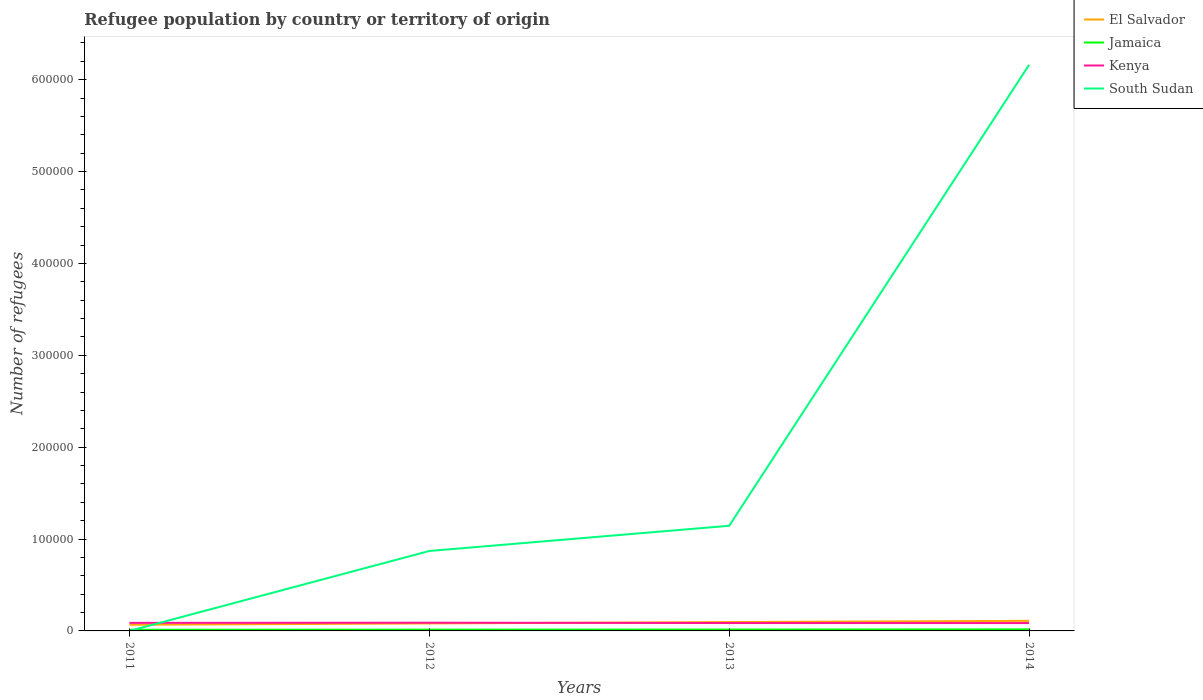Does the line corresponding to South Sudan intersect with the line corresponding to Kenya?
Make the answer very short. Yes. Across all years, what is the maximum number of refugees in El Salvador?
Provide a short and direct response. 6720. What is the total number of refugees in Kenya in the graph?
Your answer should be compact. 394. What is the difference between the highest and the second highest number of refugees in South Sudan?
Your answer should be very brief. 6.16e+05. Is the number of refugees in Jamaica strictly greater than the number of refugees in Kenya over the years?
Make the answer very short. Yes. How many years are there in the graph?
Your answer should be very brief. 4. Are the values on the major ticks of Y-axis written in scientific E-notation?
Offer a terse response. No. Does the graph contain any zero values?
Keep it short and to the point. No. Does the graph contain grids?
Provide a succinct answer. No. How many legend labels are there?
Your response must be concise. 4. What is the title of the graph?
Keep it short and to the point. Refugee population by country or territory of origin. Does "Slovak Republic" appear as one of the legend labels in the graph?
Keep it short and to the point. No. What is the label or title of the X-axis?
Ensure brevity in your answer.  Years. What is the label or title of the Y-axis?
Offer a very short reply. Number of refugees. What is the Number of refugees of El Salvador in 2011?
Ensure brevity in your answer.  6720. What is the Number of refugees of Jamaica in 2011?
Give a very brief answer. 1250. What is the Number of refugees of Kenya in 2011?
Offer a very short reply. 8745. What is the Number of refugees of South Sudan in 2011?
Provide a short and direct response. 1. What is the Number of refugees of El Salvador in 2012?
Offer a very short reply. 8171. What is the Number of refugees of Jamaica in 2012?
Your answer should be very brief. 1407. What is the Number of refugees in Kenya in 2012?
Make the answer very short. 8950. What is the Number of refugees of South Sudan in 2012?
Make the answer very short. 8.70e+04. What is the Number of refugees in El Salvador in 2013?
Keep it short and to the point. 9638. What is the Number of refugees in Jamaica in 2013?
Offer a terse response. 1503. What is the Number of refugees in Kenya in 2013?
Your answer should be very brief. 8589. What is the Number of refugees in South Sudan in 2013?
Give a very brief answer. 1.14e+05. What is the Number of refugees of El Salvador in 2014?
Give a very brief answer. 1.10e+04. What is the Number of refugees in Jamaica in 2014?
Your answer should be compact. 1692. What is the Number of refugees in Kenya in 2014?
Your answer should be compact. 8556. What is the Number of refugees of South Sudan in 2014?
Your answer should be compact. 6.16e+05. Across all years, what is the maximum Number of refugees in El Salvador?
Provide a succinct answer. 1.10e+04. Across all years, what is the maximum Number of refugees in Jamaica?
Offer a terse response. 1692. Across all years, what is the maximum Number of refugees of Kenya?
Your answer should be very brief. 8950. Across all years, what is the maximum Number of refugees of South Sudan?
Keep it short and to the point. 6.16e+05. Across all years, what is the minimum Number of refugees in El Salvador?
Ensure brevity in your answer.  6720. Across all years, what is the minimum Number of refugees in Jamaica?
Provide a succinct answer. 1250. Across all years, what is the minimum Number of refugees in Kenya?
Give a very brief answer. 8556. What is the total Number of refugees of El Salvador in the graph?
Your answer should be very brief. 3.55e+04. What is the total Number of refugees in Jamaica in the graph?
Give a very brief answer. 5852. What is the total Number of refugees in Kenya in the graph?
Ensure brevity in your answer.  3.48e+04. What is the total Number of refugees in South Sudan in the graph?
Offer a very short reply. 8.18e+05. What is the difference between the Number of refugees of El Salvador in 2011 and that in 2012?
Your answer should be very brief. -1451. What is the difference between the Number of refugees in Jamaica in 2011 and that in 2012?
Provide a succinct answer. -157. What is the difference between the Number of refugees in Kenya in 2011 and that in 2012?
Provide a short and direct response. -205. What is the difference between the Number of refugees in South Sudan in 2011 and that in 2012?
Ensure brevity in your answer.  -8.70e+04. What is the difference between the Number of refugees in El Salvador in 2011 and that in 2013?
Give a very brief answer. -2918. What is the difference between the Number of refugees in Jamaica in 2011 and that in 2013?
Your answer should be compact. -253. What is the difference between the Number of refugees of Kenya in 2011 and that in 2013?
Provide a short and direct response. 156. What is the difference between the Number of refugees in South Sudan in 2011 and that in 2013?
Your answer should be very brief. -1.14e+05. What is the difference between the Number of refugees of El Salvador in 2011 and that in 2014?
Provide a succinct answer. -4245. What is the difference between the Number of refugees in Jamaica in 2011 and that in 2014?
Provide a succinct answer. -442. What is the difference between the Number of refugees of Kenya in 2011 and that in 2014?
Your response must be concise. 189. What is the difference between the Number of refugees in South Sudan in 2011 and that in 2014?
Offer a terse response. -6.16e+05. What is the difference between the Number of refugees in El Salvador in 2012 and that in 2013?
Make the answer very short. -1467. What is the difference between the Number of refugees of Jamaica in 2012 and that in 2013?
Give a very brief answer. -96. What is the difference between the Number of refugees of Kenya in 2012 and that in 2013?
Your answer should be very brief. 361. What is the difference between the Number of refugees in South Sudan in 2012 and that in 2013?
Provide a succinct answer. -2.75e+04. What is the difference between the Number of refugees of El Salvador in 2012 and that in 2014?
Provide a succinct answer. -2794. What is the difference between the Number of refugees of Jamaica in 2012 and that in 2014?
Ensure brevity in your answer.  -285. What is the difference between the Number of refugees of Kenya in 2012 and that in 2014?
Keep it short and to the point. 394. What is the difference between the Number of refugees in South Sudan in 2012 and that in 2014?
Offer a terse response. -5.29e+05. What is the difference between the Number of refugees in El Salvador in 2013 and that in 2014?
Provide a short and direct response. -1327. What is the difference between the Number of refugees of Jamaica in 2013 and that in 2014?
Give a very brief answer. -189. What is the difference between the Number of refugees of South Sudan in 2013 and that in 2014?
Make the answer very short. -5.02e+05. What is the difference between the Number of refugees of El Salvador in 2011 and the Number of refugees of Jamaica in 2012?
Provide a short and direct response. 5313. What is the difference between the Number of refugees in El Salvador in 2011 and the Number of refugees in Kenya in 2012?
Your answer should be compact. -2230. What is the difference between the Number of refugees of El Salvador in 2011 and the Number of refugees of South Sudan in 2012?
Your response must be concise. -8.03e+04. What is the difference between the Number of refugees in Jamaica in 2011 and the Number of refugees in Kenya in 2012?
Keep it short and to the point. -7700. What is the difference between the Number of refugees in Jamaica in 2011 and the Number of refugees in South Sudan in 2012?
Offer a very short reply. -8.58e+04. What is the difference between the Number of refugees of Kenya in 2011 and the Number of refugees of South Sudan in 2012?
Ensure brevity in your answer.  -7.83e+04. What is the difference between the Number of refugees of El Salvador in 2011 and the Number of refugees of Jamaica in 2013?
Offer a terse response. 5217. What is the difference between the Number of refugees in El Salvador in 2011 and the Number of refugees in Kenya in 2013?
Give a very brief answer. -1869. What is the difference between the Number of refugees of El Salvador in 2011 and the Number of refugees of South Sudan in 2013?
Ensure brevity in your answer.  -1.08e+05. What is the difference between the Number of refugees in Jamaica in 2011 and the Number of refugees in Kenya in 2013?
Your response must be concise. -7339. What is the difference between the Number of refugees of Jamaica in 2011 and the Number of refugees of South Sudan in 2013?
Ensure brevity in your answer.  -1.13e+05. What is the difference between the Number of refugees in Kenya in 2011 and the Number of refugees in South Sudan in 2013?
Your response must be concise. -1.06e+05. What is the difference between the Number of refugees in El Salvador in 2011 and the Number of refugees in Jamaica in 2014?
Make the answer very short. 5028. What is the difference between the Number of refugees in El Salvador in 2011 and the Number of refugees in Kenya in 2014?
Provide a short and direct response. -1836. What is the difference between the Number of refugees of El Salvador in 2011 and the Number of refugees of South Sudan in 2014?
Offer a very short reply. -6.09e+05. What is the difference between the Number of refugees in Jamaica in 2011 and the Number of refugees in Kenya in 2014?
Ensure brevity in your answer.  -7306. What is the difference between the Number of refugees of Jamaica in 2011 and the Number of refugees of South Sudan in 2014?
Provide a succinct answer. -6.15e+05. What is the difference between the Number of refugees of Kenya in 2011 and the Number of refugees of South Sudan in 2014?
Provide a succinct answer. -6.07e+05. What is the difference between the Number of refugees in El Salvador in 2012 and the Number of refugees in Jamaica in 2013?
Provide a succinct answer. 6668. What is the difference between the Number of refugees of El Salvador in 2012 and the Number of refugees of Kenya in 2013?
Keep it short and to the point. -418. What is the difference between the Number of refugees of El Salvador in 2012 and the Number of refugees of South Sudan in 2013?
Your response must be concise. -1.06e+05. What is the difference between the Number of refugees in Jamaica in 2012 and the Number of refugees in Kenya in 2013?
Your answer should be very brief. -7182. What is the difference between the Number of refugees of Jamaica in 2012 and the Number of refugees of South Sudan in 2013?
Your response must be concise. -1.13e+05. What is the difference between the Number of refugees in Kenya in 2012 and the Number of refugees in South Sudan in 2013?
Offer a terse response. -1.06e+05. What is the difference between the Number of refugees of El Salvador in 2012 and the Number of refugees of Jamaica in 2014?
Your answer should be compact. 6479. What is the difference between the Number of refugees of El Salvador in 2012 and the Number of refugees of Kenya in 2014?
Your answer should be very brief. -385. What is the difference between the Number of refugees in El Salvador in 2012 and the Number of refugees in South Sudan in 2014?
Offer a very short reply. -6.08e+05. What is the difference between the Number of refugees in Jamaica in 2012 and the Number of refugees in Kenya in 2014?
Provide a succinct answer. -7149. What is the difference between the Number of refugees in Jamaica in 2012 and the Number of refugees in South Sudan in 2014?
Keep it short and to the point. -6.15e+05. What is the difference between the Number of refugees of Kenya in 2012 and the Number of refugees of South Sudan in 2014?
Your answer should be compact. -6.07e+05. What is the difference between the Number of refugees in El Salvador in 2013 and the Number of refugees in Jamaica in 2014?
Give a very brief answer. 7946. What is the difference between the Number of refugees in El Salvador in 2013 and the Number of refugees in Kenya in 2014?
Offer a terse response. 1082. What is the difference between the Number of refugees of El Salvador in 2013 and the Number of refugees of South Sudan in 2014?
Provide a succinct answer. -6.07e+05. What is the difference between the Number of refugees of Jamaica in 2013 and the Number of refugees of Kenya in 2014?
Your response must be concise. -7053. What is the difference between the Number of refugees in Jamaica in 2013 and the Number of refugees in South Sudan in 2014?
Offer a very short reply. -6.15e+05. What is the difference between the Number of refugees in Kenya in 2013 and the Number of refugees in South Sudan in 2014?
Provide a succinct answer. -6.08e+05. What is the average Number of refugees in El Salvador per year?
Your response must be concise. 8873.5. What is the average Number of refugees in Jamaica per year?
Your answer should be compact. 1463. What is the average Number of refugees in Kenya per year?
Ensure brevity in your answer.  8710. What is the average Number of refugees in South Sudan per year?
Ensure brevity in your answer.  2.04e+05. In the year 2011, what is the difference between the Number of refugees of El Salvador and Number of refugees of Jamaica?
Ensure brevity in your answer.  5470. In the year 2011, what is the difference between the Number of refugees in El Salvador and Number of refugees in Kenya?
Offer a terse response. -2025. In the year 2011, what is the difference between the Number of refugees in El Salvador and Number of refugees in South Sudan?
Provide a succinct answer. 6719. In the year 2011, what is the difference between the Number of refugees of Jamaica and Number of refugees of Kenya?
Make the answer very short. -7495. In the year 2011, what is the difference between the Number of refugees of Jamaica and Number of refugees of South Sudan?
Keep it short and to the point. 1249. In the year 2011, what is the difference between the Number of refugees in Kenya and Number of refugees in South Sudan?
Make the answer very short. 8744. In the year 2012, what is the difference between the Number of refugees of El Salvador and Number of refugees of Jamaica?
Provide a succinct answer. 6764. In the year 2012, what is the difference between the Number of refugees of El Salvador and Number of refugees of Kenya?
Offer a very short reply. -779. In the year 2012, what is the difference between the Number of refugees of El Salvador and Number of refugees of South Sudan?
Provide a short and direct response. -7.88e+04. In the year 2012, what is the difference between the Number of refugees of Jamaica and Number of refugees of Kenya?
Give a very brief answer. -7543. In the year 2012, what is the difference between the Number of refugees in Jamaica and Number of refugees in South Sudan?
Provide a short and direct response. -8.56e+04. In the year 2012, what is the difference between the Number of refugees in Kenya and Number of refugees in South Sudan?
Provide a succinct answer. -7.81e+04. In the year 2013, what is the difference between the Number of refugees of El Salvador and Number of refugees of Jamaica?
Provide a short and direct response. 8135. In the year 2013, what is the difference between the Number of refugees in El Salvador and Number of refugees in Kenya?
Offer a very short reply. 1049. In the year 2013, what is the difference between the Number of refugees of El Salvador and Number of refugees of South Sudan?
Your response must be concise. -1.05e+05. In the year 2013, what is the difference between the Number of refugees of Jamaica and Number of refugees of Kenya?
Your response must be concise. -7086. In the year 2013, what is the difference between the Number of refugees of Jamaica and Number of refugees of South Sudan?
Provide a short and direct response. -1.13e+05. In the year 2013, what is the difference between the Number of refugees in Kenya and Number of refugees in South Sudan?
Provide a succinct answer. -1.06e+05. In the year 2014, what is the difference between the Number of refugees of El Salvador and Number of refugees of Jamaica?
Offer a terse response. 9273. In the year 2014, what is the difference between the Number of refugees of El Salvador and Number of refugees of Kenya?
Give a very brief answer. 2409. In the year 2014, what is the difference between the Number of refugees of El Salvador and Number of refugees of South Sudan?
Your response must be concise. -6.05e+05. In the year 2014, what is the difference between the Number of refugees in Jamaica and Number of refugees in Kenya?
Make the answer very short. -6864. In the year 2014, what is the difference between the Number of refugees of Jamaica and Number of refugees of South Sudan?
Your answer should be compact. -6.14e+05. In the year 2014, what is the difference between the Number of refugees of Kenya and Number of refugees of South Sudan?
Provide a succinct answer. -6.08e+05. What is the ratio of the Number of refugees of El Salvador in 2011 to that in 2012?
Provide a short and direct response. 0.82. What is the ratio of the Number of refugees in Jamaica in 2011 to that in 2012?
Provide a succinct answer. 0.89. What is the ratio of the Number of refugees in Kenya in 2011 to that in 2012?
Your response must be concise. 0.98. What is the ratio of the Number of refugees in El Salvador in 2011 to that in 2013?
Provide a succinct answer. 0.7. What is the ratio of the Number of refugees of Jamaica in 2011 to that in 2013?
Your answer should be compact. 0.83. What is the ratio of the Number of refugees of Kenya in 2011 to that in 2013?
Offer a terse response. 1.02. What is the ratio of the Number of refugees of El Salvador in 2011 to that in 2014?
Ensure brevity in your answer.  0.61. What is the ratio of the Number of refugees in Jamaica in 2011 to that in 2014?
Offer a very short reply. 0.74. What is the ratio of the Number of refugees in Kenya in 2011 to that in 2014?
Your answer should be compact. 1.02. What is the ratio of the Number of refugees in South Sudan in 2011 to that in 2014?
Keep it short and to the point. 0. What is the ratio of the Number of refugees in El Salvador in 2012 to that in 2013?
Provide a succinct answer. 0.85. What is the ratio of the Number of refugees of Jamaica in 2012 to that in 2013?
Your answer should be compact. 0.94. What is the ratio of the Number of refugees in Kenya in 2012 to that in 2013?
Offer a very short reply. 1.04. What is the ratio of the Number of refugees of South Sudan in 2012 to that in 2013?
Provide a short and direct response. 0.76. What is the ratio of the Number of refugees in El Salvador in 2012 to that in 2014?
Ensure brevity in your answer.  0.75. What is the ratio of the Number of refugees of Jamaica in 2012 to that in 2014?
Keep it short and to the point. 0.83. What is the ratio of the Number of refugees in Kenya in 2012 to that in 2014?
Your answer should be very brief. 1.05. What is the ratio of the Number of refugees of South Sudan in 2012 to that in 2014?
Provide a short and direct response. 0.14. What is the ratio of the Number of refugees of El Salvador in 2013 to that in 2014?
Provide a short and direct response. 0.88. What is the ratio of the Number of refugees of Jamaica in 2013 to that in 2014?
Provide a short and direct response. 0.89. What is the ratio of the Number of refugees of Kenya in 2013 to that in 2014?
Give a very brief answer. 1. What is the ratio of the Number of refugees of South Sudan in 2013 to that in 2014?
Provide a short and direct response. 0.19. What is the difference between the highest and the second highest Number of refugees of El Salvador?
Your answer should be compact. 1327. What is the difference between the highest and the second highest Number of refugees in Jamaica?
Provide a short and direct response. 189. What is the difference between the highest and the second highest Number of refugees of Kenya?
Make the answer very short. 205. What is the difference between the highest and the second highest Number of refugees of South Sudan?
Your answer should be very brief. 5.02e+05. What is the difference between the highest and the lowest Number of refugees in El Salvador?
Your answer should be very brief. 4245. What is the difference between the highest and the lowest Number of refugees in Jamaica?
Provide a succinct answer. 442. What is the difference between the highest and the lowest Number of refugees in Kenya?
Offer a terse response. 394. What is the difference between the highest and the lowest Number of refugees of South Sudan?
Make the answer very short. 6.16e+05. 